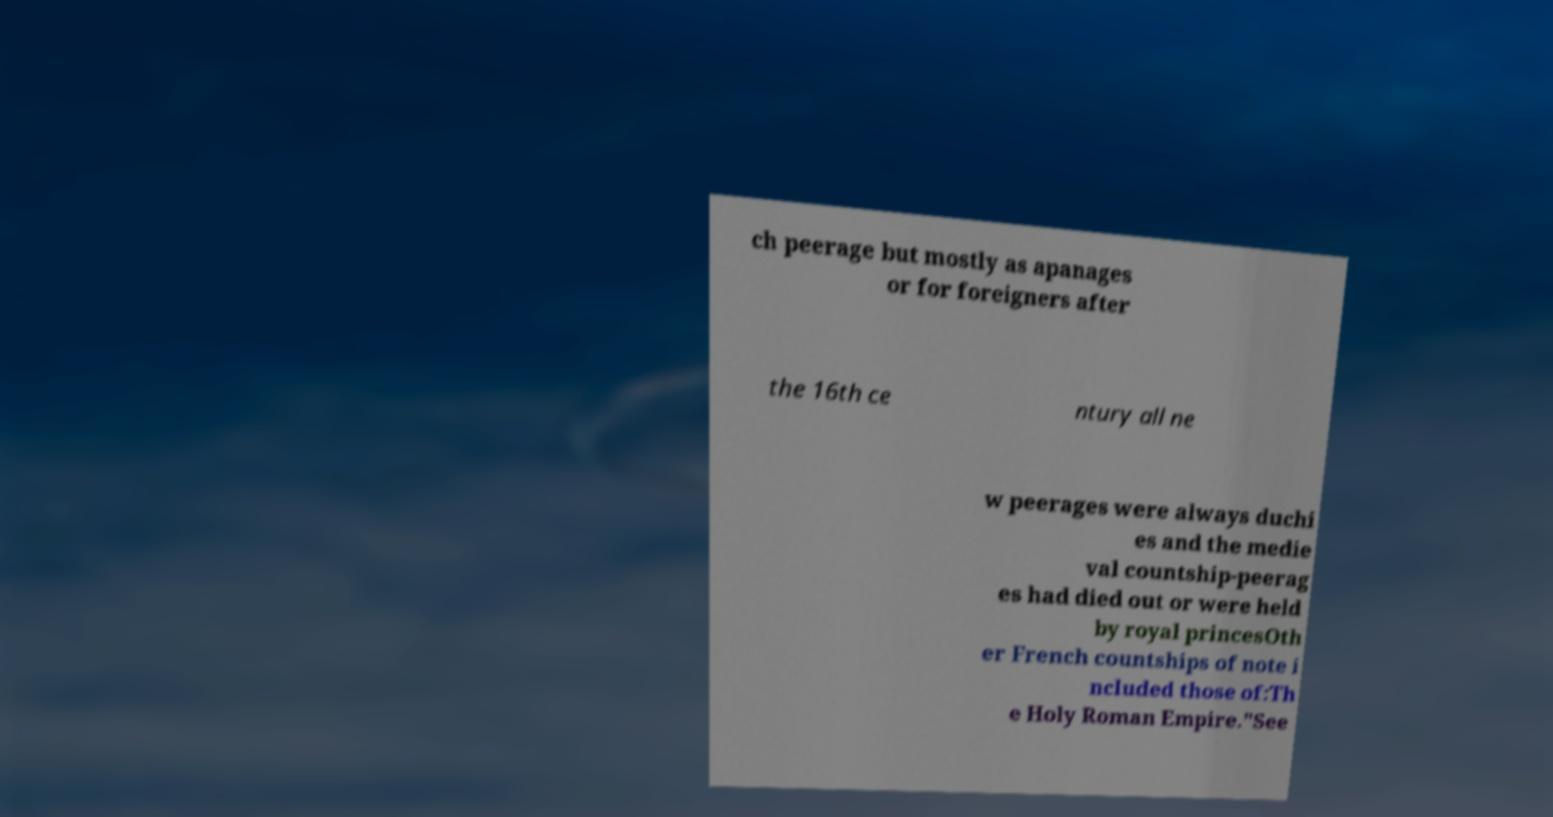Can you read and provide the text displayed in the image?This photo seems to have some interesting text. Can you extract and type it out for me? ch peerage but mostly as apanages or for foreigners after the 16th ce ntury all ne w peerages were always duchi es and the medie val countship-peerag es had died out or were held by royal princesOth er French countships of note i ncluded those of:Th e Holy Roman Empire."See 